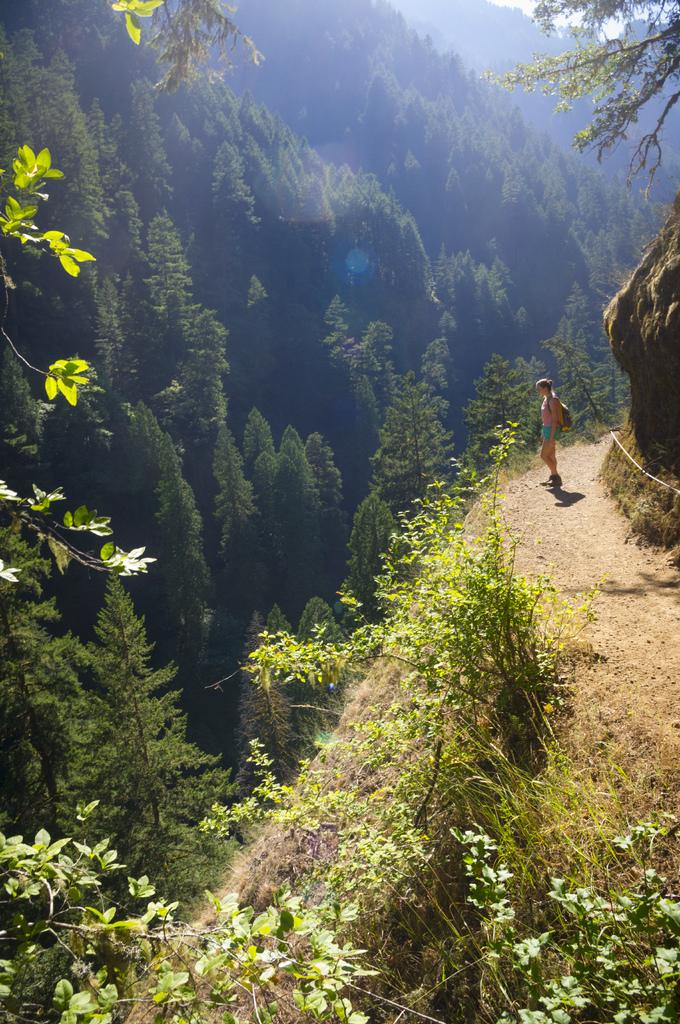Who is present in the image? There is a woman in the image. What is the woman carrying? The woman is carrying a bag. What type of vegetation can be seen in the image? There are plants, grass, and trees in the image. What can be seen in the background of the image? The sky is visible in the background of the image. What kind of trouble is the minister causing in the image? There is no minister present in the image, and therefore no trouble can be attributed to a minister. 